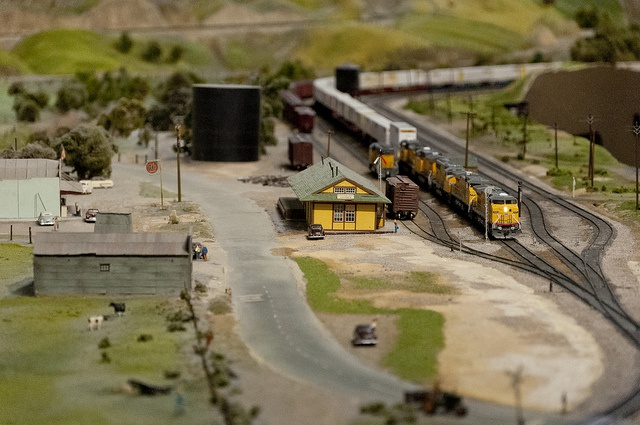Describe the objects in this image and their specific colors. I can see train in gray, black, darkgray, and olive tones, train in gray, black, and maroon tones, car in gray and black tones, cow in gray and tan tones, and car in gray, darkgray, and lightgray tones in this image. 